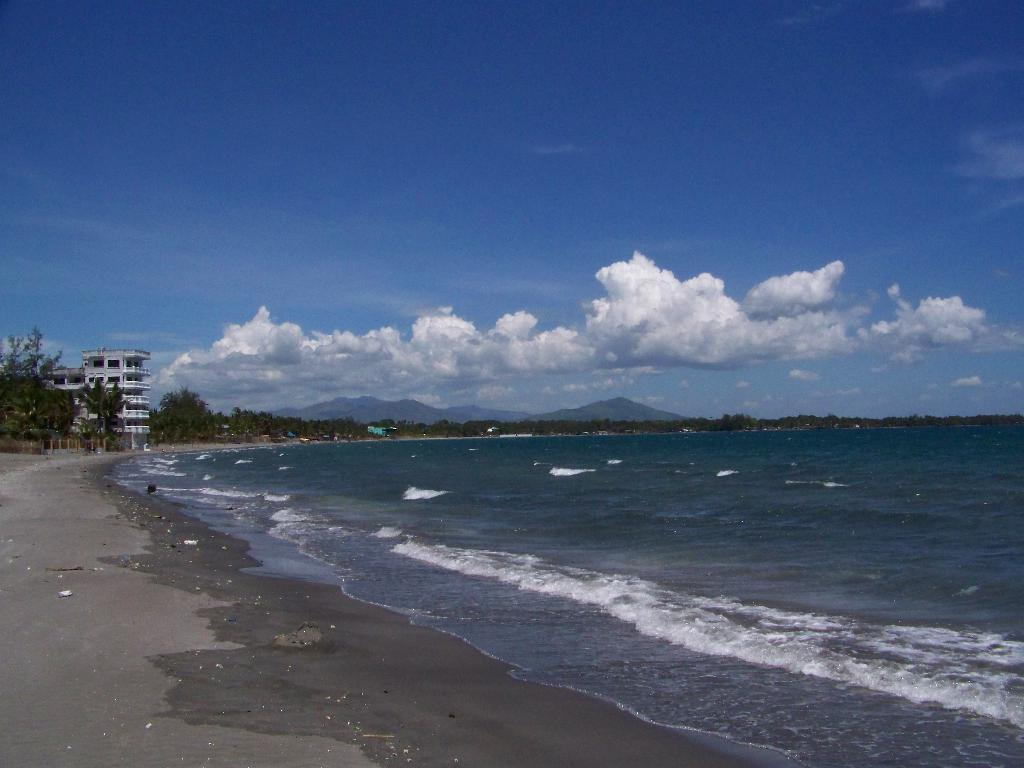What is the primary element visible in the image? There is water in the image. What type of natural vegetation can be seen in the image? There are trees in the image. What type of man-made structures are present in the image? There are buildings in the image. What is visible in the sky in the image? There are clouds in the sky in the image. What type of lettuce can be seen growing near the buildings in the image? There is no lettuce visible in the image; the focus is on water, trees, buildings, and clouds. 